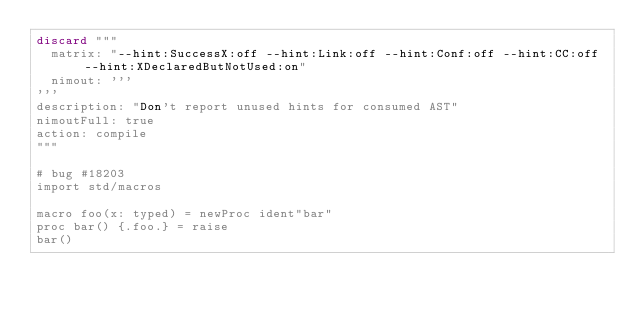Convert code to text. <code><loc_0><loc_0><loc_500><loc_500><_Nim_>discard """
  matrix: "--hint:SuccessX:off --hint:Link:off --hint:Conf:off --hint:CC:off --hint:XDeclaredButNotUsed:on"
  nimout: '''
'''
description: "Don't report unused hints for consumed AST"
nimoutFull: true
action: compile
"""

# bug #18203
import std/macros

macro foo(x: typed) = newProc ident"bar"
proc bar() {.foo.} = raise
bar()

</code> 